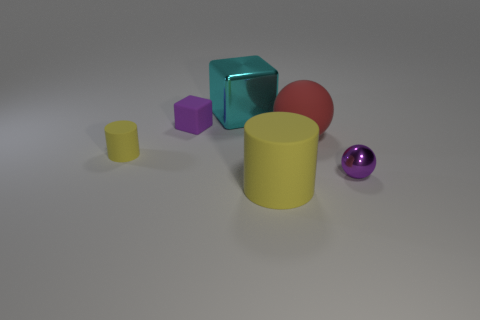The other object that is the same shape as the large yellow rubber thing is what color?
Your answer should be very brief. Yellow. There is a yellow object left of the purple rubber object; does it have the same size as the tiny purple cube?
Provide a short and direct response. Yes. What is the shape of the tiny metallic thing that is the same color as the small cube?
Your answer should be compact. Sphere. What number of tiny spheres are the same material as the small cylinder?
Offer a very short reply. 0. The yellow cylinder that is in front of the yellow rubber cylinder that is behind the large yellow matte cylinder left of the red ball is made of what material?
Offer a very short reply. Rubber. There is a metal thing left of the yellow matte cylinder that is in front of the tiny yellow rubber thing; what is its color?
Make the answer very short. Cyan. The rubber cylinder that is the same size as the shiny sphere is what color?
Ensure brevity in your answer.  Yellow. Are there more things behind the big red thing than small spheres that are on the left side of the large cyan cube?
Your response must be concise. Yes. The rubber thing that is the same color as the small rubber cylinder is what size?
Provide a short and direct response. Large. How many other objects are there of the same size as the purple matte cube?
Provide a short and direct response. 2. 